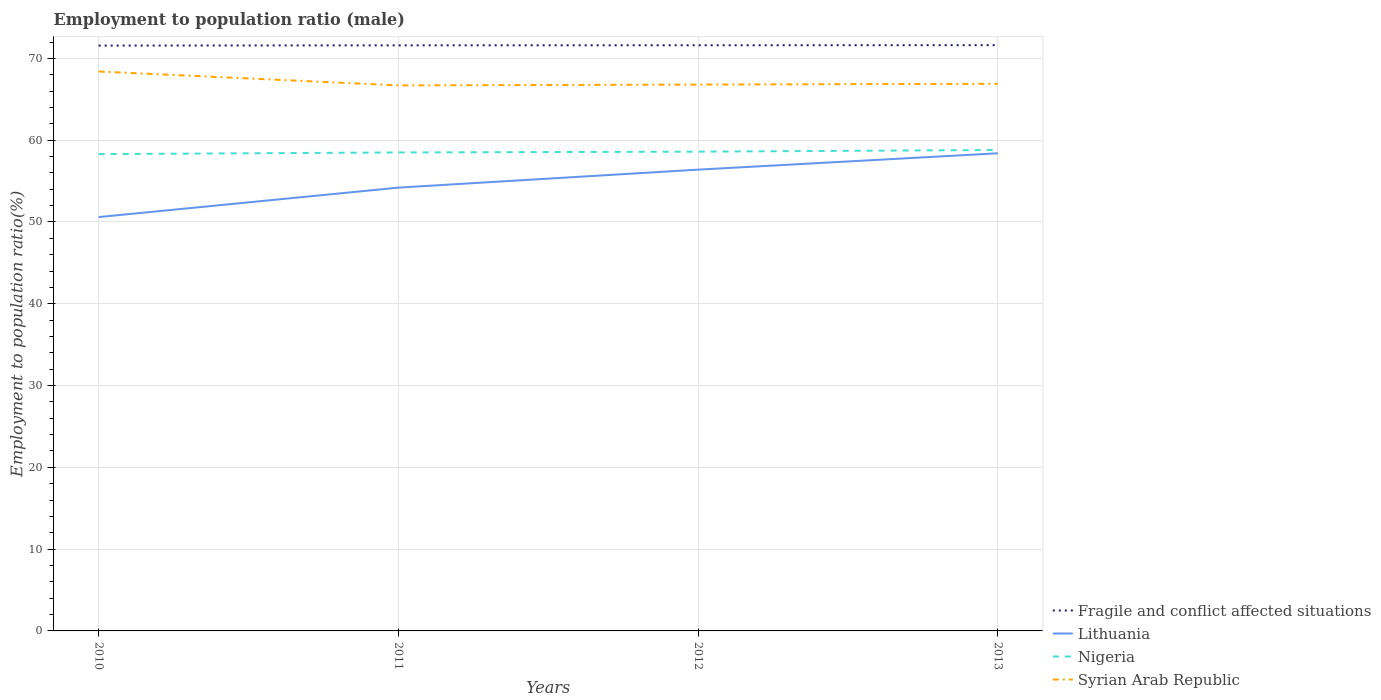How many different coloured lines are there?
Keep it short and to the point. 4. Across all years, what is the maximum employment to population ratio in Lithuania?
Your answer should be compact. 50.6. What is the total employment to population ratio in Syrian Arab Republic in the graph?
Your response must be concise. 1.7. What is the difference between two consecutive major ticks on the Y-axis?
Give a very brief answer. 10. Where does the legend appear in the graph?
Your answer should be very brief. Bottom right. How are the legend labels stacked?
Make the answer very short. Vertical. What is the title of the graph?
Provide a succinct answer. Employment to population ratio (male). What is the label or title of the X-axis?
Keep it short and to the point. Years. What is the Employment to population ratio(%) of Fragile and conflict affected situations in 2010?
Offer a very short reply. 71.57. What is the Employment to population ratio(%) of Lithuania in 2010?
Provide a succinct answer. 50.6. What is the Employment to population ratio(%) of Nigeria in 2010?
Provide a short and direct response. 58.3. What is the Employment to population ratio(%) in Syrian Arab Republic in 2010?
Your response must be concise. 68.4. What is the Employment to population ratio(%) in Fragile and conflict affected situations in 2011?
Provide a short and direct response. 71.6. What is the Employment to population ratio(%) of Lithuania in 2011?
Your answer should be very brief. 54.2. What is the Employment to population ratio(%) of Nigeria in 2011?
Ensure brevity in your answer.  58.5. What is the Employment to population ratio(%) in Syrian Arab Republic in 2011?
Provide a short and direct response. 66.7. What is the Employment to population ratio(%) in Fragile and conflict affected situations in 2012?
Offer a very short reply. 71.61. What is the Employment to population ratio(%) of Lithuania in 2012?
Keep it short and to the point. 56.4. What is the Employment to population ratio(%) of Nigeria in 2012?
Your answer should be compact. 58.6. What is the Employment to population ratio(%) of Syrian Arab Republic in 2012?
Keep it short and to the point. 66.8. What is the Employment to population ratio(%) of Fragile and conflict affected situations in 2013?
Your answer should be compact. 71.62. What is the Employment to population ratio(%) of Lithuania in 2013?
Provide a succinct answer. 58.4. What is the Employment to population ratio(%) in Nigeria in 2013?
Keep it short and to the point. 58.8. What is the Employment to population ratio(%) of Syrian Arab Republic in 2013?
Offer a very short reply. 66.9. Across all years, what is the maximum Employment to population ratio(%) in Fragile and conflict affected situations?
Your response must be concise. 71.62. Across all years, what is the maximum Employment to population ratio(%) of Lithuania?
Offer a terse response. 58.4. Across all years, what is the maximum Employment to population ratio(%) of Nigeria?
Keep it short and to the point. 58.8. Across all years, what is the maximum Employment to population ratio(%) in Syrian Arab Republic?
Provide a short and direct response. 68.4. Across all years, what is the minimum Employment to population ratio(%) in Fragile and conflict affected situations?
Offer a very short reply. 71.57. Across all years, what is the minimum Employment to population ratio(%) of Lithuania?
Provide a succinct answer. 50.6. Across all years, what is the minimum Employment to population ratio(%) of Nigeria?
Give a very brief answer. 58.3. Across all years, what is the minimum Employment to population ratio(%) of Syrian Arab Republic?
Offer a very short reply. 66.7. What is the total Employment to population ratio(%) of Fragile and conflict affected situations in the graph?
Your answer should be very brief. 286.39. What is the total Employment to population ratio(%) in Lithuania in the graph?
Your answer should be compact. 219.6. What is the total Employment to population ratio(%) in Nigeria in the graph?
Provide a short and direct response. 234.2. What is the total Employment to population ratio(%) of Syrian Arab Republic in the graph?
Give a very brief answer. 268.8. What is the difference between the Employment to population ratio(%) of Fragile and conflict affected situations in 2010 and that in 2011?
Make the answer very short. -0.03. What is the difference between the Employment to population ratio(%) in Lithuania in 2010 and that in 2011?
Give a very brief answer. -3.6. What is the difference between the Employment to population ratio(%) of Syrian Arab Republic in 2010 and that in 2011?
Offer a terse response. 1.7. What is the difference between the Employment to population ratio(%) in Fragile and conflict affected situations in 2010 and that in 2012?
Your answer should be very brief. -0.04. What is the difference between the Employment to population ratio(%) in Syrian Arab Republic in 2010 and that in 2012?
Your response must be concise. 1.6. What is the difference between the Employment to population ratio(%) of Fragile and conflict affected situations in 2010 and that in 2013?
Your answer should be compact. -0.05. What is the difference between the Employment to population ratio(%) in Lithuania in 2010 and that in 2013?
Ensure brevity in your answer.  -7.8. What is the difference between the Employment to population ratio(%) of Fragile and conflict affected situations in 2011 and that in 2012?
Your response must be concise. -0.01. What is the difference between the Employment to population ratio(%) of Lithuania in 2011 and that in 2012?
Make the answer very short. -2.2. What is the difference between the Employment to population ratio(%) of Nigeria in 2011 and that in 2012?
Your answer should be very brief. -0.1. What is the difference between the Employment to population ratio(%) of Syrian Arab Republic in 2011 and that in 2012?
Your response must be concise. -0.1. What is the difference between the Employment to population ratio(%) of Fragile and conflict affected situations in 2011 and that in 2013?
Ensure brevity in your answer.  -0.02. What is the difference between the Employment to population ratio(%) in Syrian Arab Republic in 2011 and that in 2013?
Ensure brevity in your answer.  -0.2. What is the difference between the Employment to population ratio(%) of Fragile and conflict affected situations in 2012 and that in 2013?
Ensure brevity in your answer.  -0.01. What is the difference between the Employment to population ratio(%) of Nigeria in 2012 and that in 2013?
Provide a succinct answer. -0.2. What is the difference between the Employment to population ratio(%) of Fragile and conflict affected situations in 2010 and the Employment to population ratio(%) of Lithuania in 2011?
Your response must be concise. 17.37. What is the difference between the Employment to population ratio(%) in Fragile and conflict affected situations in 2010 and the Employment to population ratio(%) in Nigeria in 2011?
Offer a very short reply. 13.07. What is the difference between the Employment to population ratio(%) in Fragile and conflict affected situations in 2010 and the Employment to population ratio(%) in Syrian Arab Republic in 2011?
Provide a succinct answer. 4.87. What is the difference between the Employment to population ratio(%) of Lithuania in 2010 and the Employment to population ratio(%) of Nigeria in 2011?
Give a very brief answer. -7.9. What is the difference between the Employment to population ratio(%) of Lithuania in 2010 and the Employment to population ratio(%) of Syrian Arab Republic in 2011?
Your response must be concise. -16.1. What is the difference between the Employment to population ratio(%) in Fragile and conflict affected situations in 2010 and the Employment to population ratio(%) in Lithuania in 2012?
Ensure brevity in your answer.  15.17. What is the difference between the Employment to population ratio(%) of Fragile and conflict affected situations in 2010 and the Employment to population ratio(%) of Nigeria in 2012?
Provide a succinct answer. 12.97. What is the difference between the Employment to population ratio(%) of Fragile and conflict affected situations in 2010 and the Employment to population ratio(%) of Syrian Arab Republic in 2012?
Keep it short and to the point. 4.77. What is the difference between the Employment to population ratio(%) of Lithuania in 2010 and the Employment to population ratio(%) of Syrian Arab Republic in 2012?
Keep it short and to the point. -16.2. What is the difference between the Employment to population ratio(%) in Nigeria in 2010 and the Employment to population ratio(%) in Syrian Arab Republic in 2012?
Offer a terse response. -8.5. What is the difference between the Employment to population ratio(%) in Fragile and conflict affected situations in 2010 and the Employment to population ratio(%) in Lithuania in 2013?
Keep it short and to the point. 13.17. What is the difference between the Employment to population ratio(%) in Fragile and conflict affected situations in 2010 and the Employment to population ratio(%) in Nigeria in 2013?
Provide a short and direct response. 12.77. What is the difference between the Employment to population ratio(%) of Fragile and conflict affected situations in 2010 and the Employment to population ratio(%) of Syrian Arab Republic in 2013?
Make the answer very short. 4.67. What is the difference between the Employment to population ratio(%) in Lithuania in 2010 and the Employment to population ratio(%) in Syrian Arab Republic in 2013?
Your response must be concise. -16.3. What is the difference between the Employment to population ratio(%) of Fragile and conflict affected situations in 2011 and the Employment to population ratio(%) of Lithuania in 2012?
Offer a very short reply. 15.2. What is the difference between the Employment to population ratio(%) of Fragile and conflict affected situations in 2011 and the Employment to population ratio(%) of Nigeria in 2012?
Ensure brevity in your answer.  13. What is the difference between the Employment to population ratio(%) in Fragile and conflict affected situations in 2011 and the Employment to population ratio(%) in Syrian Arab Republic in 2012?
Provide a succinct answer. 4.8. What is the difference between the Employment to population ratio(%) of Lithuania in 2011 and the Employment to population ratio(%) of Syrian Arab Republic in 2012?
Ensure brevity in your answer.  -12.6. What is the difference between the Employment to population ratio(%) in Nigeria in 2011 and the Employment to population ratio(%) in Syrian Arab Republic in 2012?
Offer a terse response. -8.3. What is the difference between the Employment to population ratio(%) of Fragile and conflict affected situations in 2011 and the Employment to population ratio(%) of Lithuania in 2013?
Provide a short and direct response. 13.2. What is the difference between the Employment to population ratio(%) in Fragile and conflict affected situations in 2011 and the Employment to population ratio(%) in Nigeria in 2013?
Provide a short and direct response. 12.8. What is the difference between the Employment to population ratio(%) in Fragile and conflict affected situations in 2011 and the Employment to population ratio(%) in Syrian Arab Republic in 2013?
Provide a short and direct response. 4.7. What is the difference between the Employment to population ratio(%) in Nigeria in 2011 and the Employment to population ratio(%) in Syrian Arab Republic in 2013?
Give a very brief answer. -8.4. What is the difference between the Employment to population ratio(%) in Fragile and conflict affected situations in 2012 and the Employment to population ratio(%) in Lithuania in 2013?
Make the answer very short. 13.21. What is the difference between the Employment to population ratio(%) in Fragile and conflict affected situations in 2012 and the Employment to population ratio(%) in Nigeria in 2013?
Ensure brevity in your answer.  12.81. What is the difference between the Employment to population ratio(%) of Fragile and conflict affected situations in 2012 and the Employment to population ratio(%) of Syrian Arab Republic in 2013?
Your answer should be compact. 4.71. What is the difference between the Employment to population ratio(%) of Lithuania in 2012 and the Employment to population ratio(%) of Nigeria in 2013?
Your response must be concise. -2.4. What is the difference between the Employment to population ratio(%) of Lithuania in 2012 and the Employment to population ratio(%) of Syrian Arab Republic in 2013?
Provide a succinct answer. -10.5. What is the difference between the Employment to population ratio(%) of Nigeria in 2012 and the Employment to population ratio(%) of Syrian Arab Republic in 2013?
Keep it short and to the point. -8.3. What is the average Employment to population ratio(%) in Fragile and conflict affected situations per year?
Offer a very short reply. 71.6. What is the average Employment to population ratio(%) in Lithuania per year?
Your answer should be compact. 54.9. What is the average Employment to population ratio(%) of Nigeria per year?
Ensure brevity in your answer.  58.55. What is the average Employment to population ratio(%) of Syrian Arab Republic per year?
Your answer should be very brief. 67.2. In the year 2010, what is the difference between the Employment to population ratio(%) in Fragile and conflict affected situations and Employment to population ratio(%) in Lithuania?
Offer a very short reply. 20.97. In the year 2010, what is the difference between the Employment to population ratio(%) of Fragile and conflict affected situations and Employment to population ratio(%) of Nigeria?
Make the answer very short. 13.27. In the year 2010, what is the difference between the Employment to population ratio(%) in Fragile and conflict affected situations and Employment to population ratio(%) in Syrian Arab Republic?
Your answer should be compact. 3.17. In the year 2010, what is the difference between the Employment to population ratio(%) of Lithuania and Employment to population ratio(%) of Syrian Arab Republic?
Provide a succinct answer. -17.8. In the year 2010, what is the difference between the Employment to population ratio(%) of Nigeria and Employment to population ratio(%) of Syrian Arab Republic?
Give a very brief answer. -10.1. In the year 2011, what is the difference between the Employment to population ratio(%) of Fragile and conflict affected situations and Employment to population ratio(%) of Lithuania?
Provide a short and direct response. 17.4. In the year 2011, what is the difference between the Employment to population ratio(%) of Fragile and conflict affected situations and Employment to population ratio(%) of Nigeria?
Offer a very short reply. 13.1. In the year 2011, what is the difference between the Employment to population ratio(%) of Fragile and conflict affected situations and Employment to population ratio(%) of Syrian Arab Republic?
Provide a short and direct response. 4.9. In the year 2011, what is the difference between the Employment to population ratio(%) in Lithuania and Employment to population ratio(%) in Nigeria?
Provide a succinct answer. -4.3. In the year 2011, what is the difference between the Employment to population ratio(%) of Nigeria and Employment to population ratio(%) of Syrian Arab Republic?
Offer a terse response. -8.2. In the year 2012, what is the difference between the Employment to population ratio(%) of Fragile and conflict affected situations and Employment to population ratio(%) of Lithuania?
Offer a terse response. 15.21. In the year 2012, what is the difference between the Employment to population ratio(%) of Fragile and conflict affected situations and Employment to population ratio(%) of Nigeria?
Offer a terse response. 13.01. In the year 2012, what is the difference between the Employment to population ratio(%) in Fragile and conflict affected situations and Employment to population ratio(%) in Syrian Arab Republic?
Ensure brevity in your answer.  4.81. In the year 2012, what is the difference between the Employment to population ratio(%) in Lithuania and Employment to population ratio(%) in Nigeria?
Your answer should be compact. -2.2. In the year 2012, what is the difference between the Employment to population ratio(%) in Lithuania and Employment to population ratio(%) in Syrian Arab Republic?
Your answer should be compact. -10.4. In the year 2013, what is the difference between the Employment to population ratio(%) of Fragile and conflict affected situations and Employment to population ratio(%) of Lithuania?
Your response must be concise. 13.22. In the year 2013, what is the difference between the Employment to population ratio(%) of Fragile and conflict affected situations and Employment to population ratio(%) of Nigeria?
Make the answer very short. 12.82. In the year 2013, what is the difference between the Employment to population ratio(%) in Fragile and conflict affected situations and Employment to population ratio(%) in Syrian Arab Republic?
Your answer should be compact. 4.72. In the year 2013, what is the difference between the Employment to population ratio(%) of Lithuania and Employment to population ratio(%) of Nigeria?
Offer a very short reply. -0.4. What is the ratio of the Employment to population ratio(%) in Lithuania in 2010 to that in 2011?
Provide a short and direct response. 0.93. What is the ratio of the Employment to population ratio(%) in Nigeria in 2010 to that in 2011?
Your answer should be compact. 1. What is the ratio of the Employment to population ratio(%) of Syrian Arab Republic in 2010 to that in 2011?
Keep it short and to the point. 1.03. What is the ratio of the Employment to population ratio(%) of Lithuania in 2010 to that in 2012?
Keep it short and to the point. 0.9. What is the ratio of the Employment to population ratio(%) of Nigeria in 2010 to that in 2012?
Offer a very short reply. 0.99. What is the ratio of the Employment to population ratio(%) of Syrian Arab Republic in 2010 to that in 2012?
Give a very brief answer. 1.02. What is the ratio of the Employment to population ratio(%) of Fragile and conflict affected situations in 2010 to that in 2013?
Your response must be concise. 1. What is the ratio of the Employment to population ratio(%) of Lithuania in 2010 to that in 2013?
Offer a terse response. 0.87. What is the ratio of the Employment to population ratio(%) of Nigeria in 2010 to that in 2013?
Provide a succinct answer. 0.99. What is the ratio of the Employment to population ratio(%) in Syrian Arab Republic in 2010 to that in 2013?
Your answer should be compact. 1.02. What is the ratio of the Employment to population ratio(%) of Fragile and conflict affected situations in 2011 to that in 2012?
Ensure brevity in your answer.  1. What is the ratio of the Employment to population ratio(%) of Lithuania in 2011 to that in 2012?
Your response must be concise. 0.96. What is the ratio of the Employment to population ratio(%) in Nigeria in 2011 to that in 2012?
Provide a succinct answer. 1. What is the ratio of the Employment to population ratio(%) of Syrian Arab Republic in 2011 to that in 2012?
Offer a very short reply. 1. What is the ratio of the Employment to population ratio(%) of Fragile and conflict affected situations in 2011 to that in 2013?
Ensure brevity in your answer.  1. What is the ratio of the Employment to population ratio(%) of Lithuania in 2011 to that in 2013?
Give a very brief answer. 0.93. What is the ratio of the Employment to population ratio(%) of Nigeria in 2011 to that in 2013?
Your answer should be very brief. 0.99. What is the ratio of the Employment to population ratio(%) of Syrian Arab Republic in 2011 to that in 2013?
Your response must be concise. 1. What is the ratio of the Employment to population ratio(%) in Fragile and conflict affected situations in 2012 to that in 2013?
Your answer should be very brief. 1. What is the ratio of the Employment to population ratio(%) of Lithuania in 2012 to that in 2013?
Make the answer very short. 0.97. What is the ratio of the Employment to population ratio(%) in Nigeria in 2012 to that in 2013?
Ensure brevity in your answer.  1. What is the difference between the highest and the second highest Employment to population ratio(%) of Fragile and conflict affected situations?
Offer a very short reply. 0.01. What is the difference between the highest and the second highest Employment to population ratio(%) in Lithuania?
Your response must be concise. 2. What is the difference between the highest and the second highest Employment to population ratio(%) in Nigeria?
Make the answer very short. 0.2. What is the difference between the highest and the lowest Employment to population ratio(%) of Fragile and conflict affected situations?
Provide a short and direct response. 0.05. 